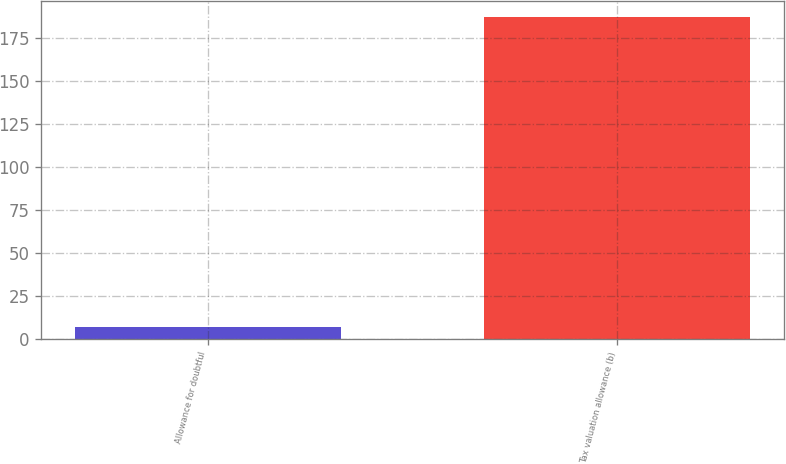Convert chart. <chart><loc_0><loc_0><loc_500><loc_500><bar_chart><fcel>Allowance for doubtful<fcel>Tax valuation allowance (b)<nl><fcel>7<fcel>187<nl></chart> 